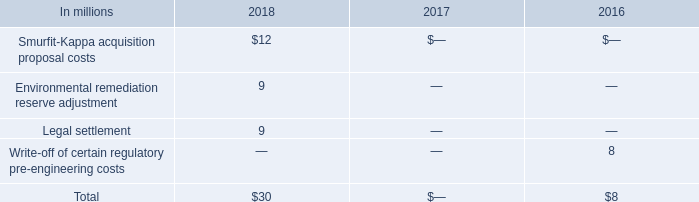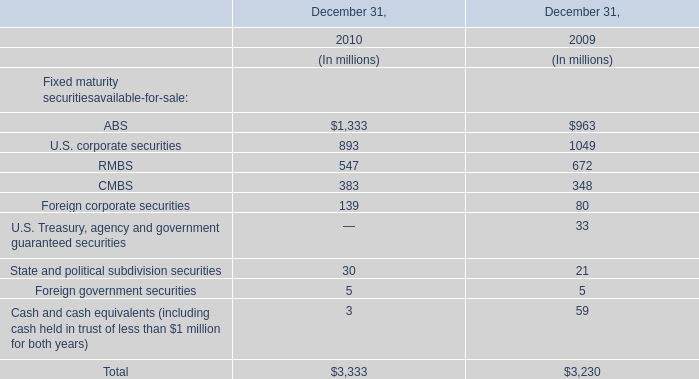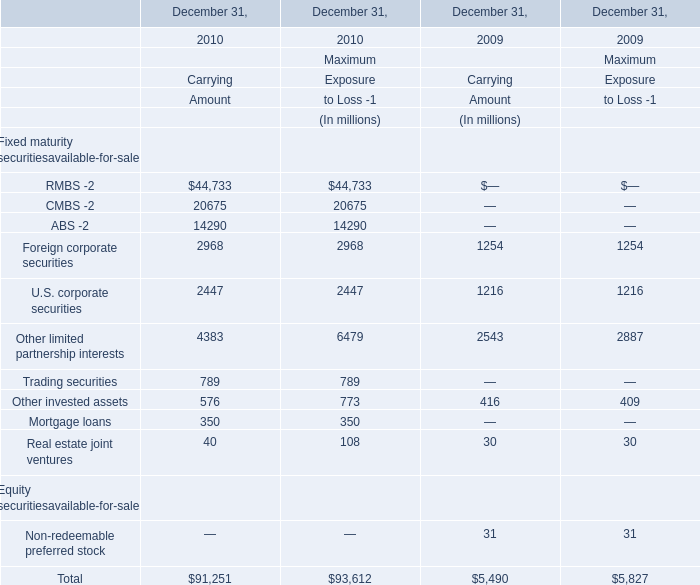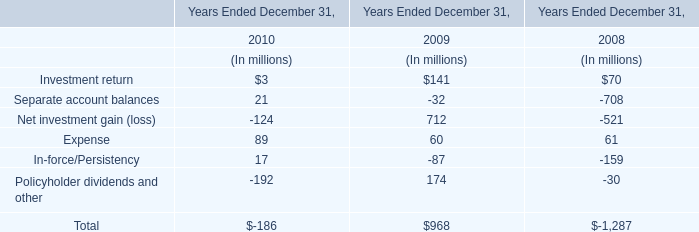If RMBS develops with the same increasing rate in 2010, what will it reach in 2011? (in million) 
Computations: ((1 + ((547 - 672) / 672)) * 547)
Answer: 445.25149. 